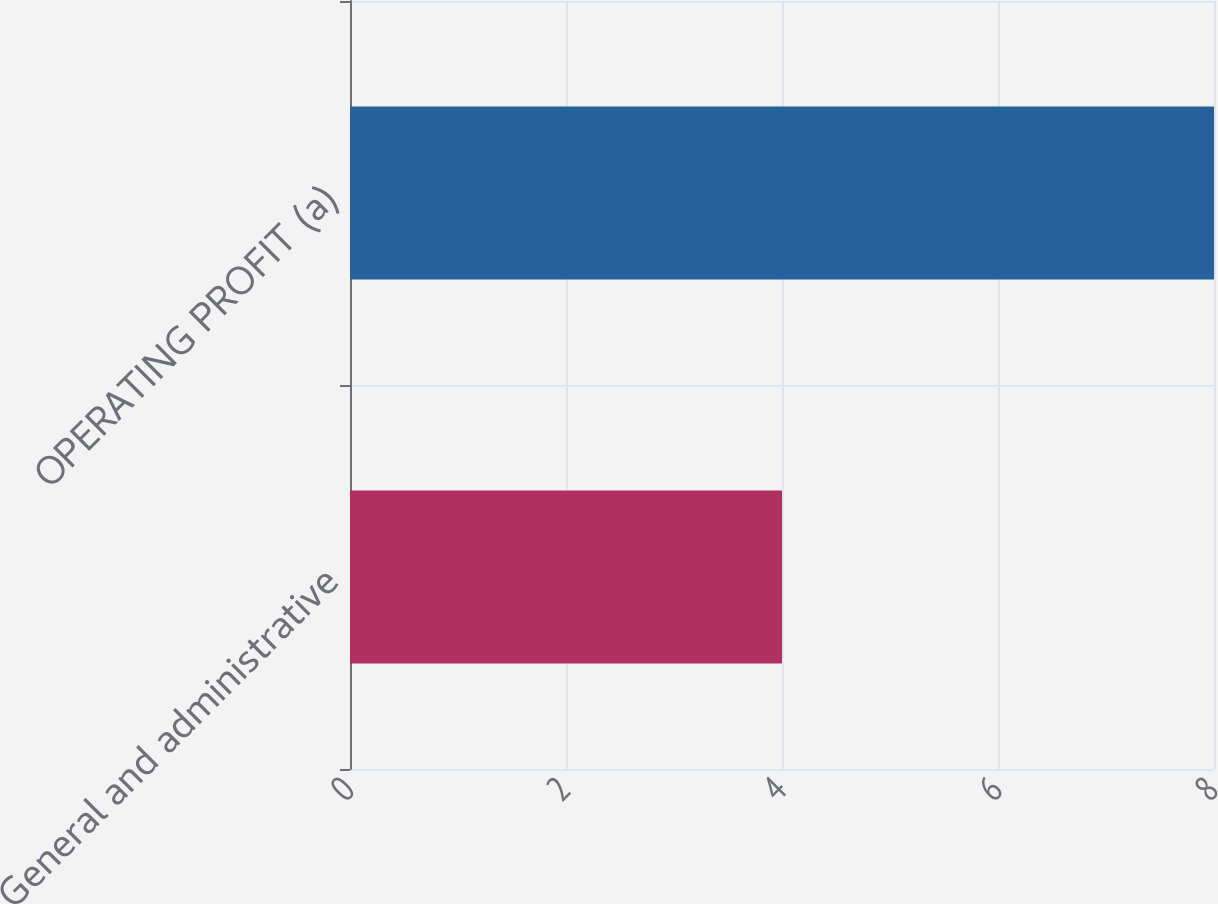Convert chart. <chart><loc_0><loc_0><loc_500><loc_500><bar_chart><fcel>General and administrative<fcel>OPERATING PROFIT (a)<nl><fcel>4<fcel>8<nl></chart> 